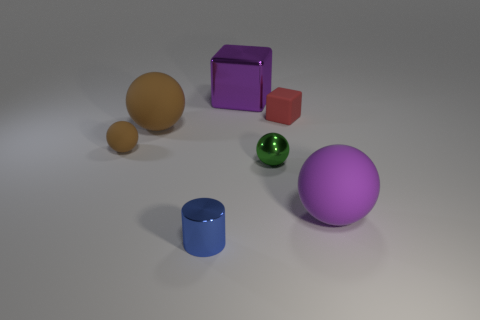What is the material of the big sphere that is on the right side of the cube to the left of the tiny red object?
Your answer should be very brief. Rubber. Are there any metal things of the same color as the small shiny ball?
Your answer should be compact. No. There is a metallic sphere that is the same size as the blue object; what color is it?
Your answer should be very brief. Green. The big purple object that is left of the small ball in front of the tiny rubber object that is left of the cylinder is made of what material?
Give a very brief answer. Metal. There is a cylinder; is its color the same as the tiny rubber object in front of the red matte cube?
Provide a short and direct response. No. What number of things are either purple things that are on the left side of the red object or large rubber balls left of the green shiny ball?
Make the answer very short. 2. What shape is the large rubber thing left of the purple object to the right of the red object?
Give a very brief answer. Sphere. Are there any other balls made of the same material as the green ball?
Your response must be concise. No. What color is the shiny object that is the same shape as the tiny brown rubber object?
Your answer should be compact. Green. Are there fewer red blocks to the left of the metallic cylinder than brown rubber balls right of the green shiny sphere?
Offer a very short reply. No. 